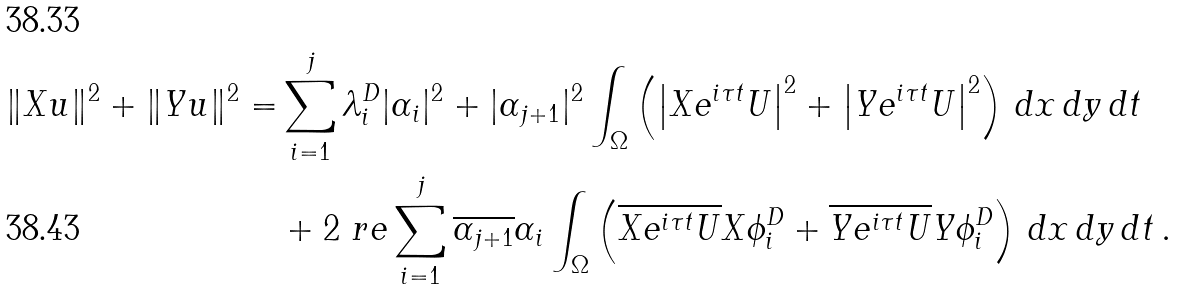<formula> <loc_0><loc_0><loc_500><loc_500>\| X u \| ^ { 2 } + \| Y u \| ^ { 2 } = & \sum _ { i = 1 } ^ { j } \lambda _ { i } ^ { D } | \alpha _ { i } | ^ { 2 } + | \alpha _ { j + 1 } | ^ { 2 } \int _ { \Omega } \left ( \left | X e ^ { i \tau t } U \right | ^ { 2 } + \left | Y e ^ { i \tau t } U \right | ^ { 2 } \right ) \, d x \, d y \, d t \\ & + 2 \ r e \sum _ { i = 1 } ^ { j } \overline { \alpha _ { j + 1 } } \alpha _ { i } \int _ { \Omega } \left ( \overline { X e ^ { i \tau t } U } X \phi _ { i } ^ { D } + \overline { Y e ^ { i \tau t } U } Y \phi _ { i } ^ { D } \right ) \, d x \, d y \, d t \, .</formula> 